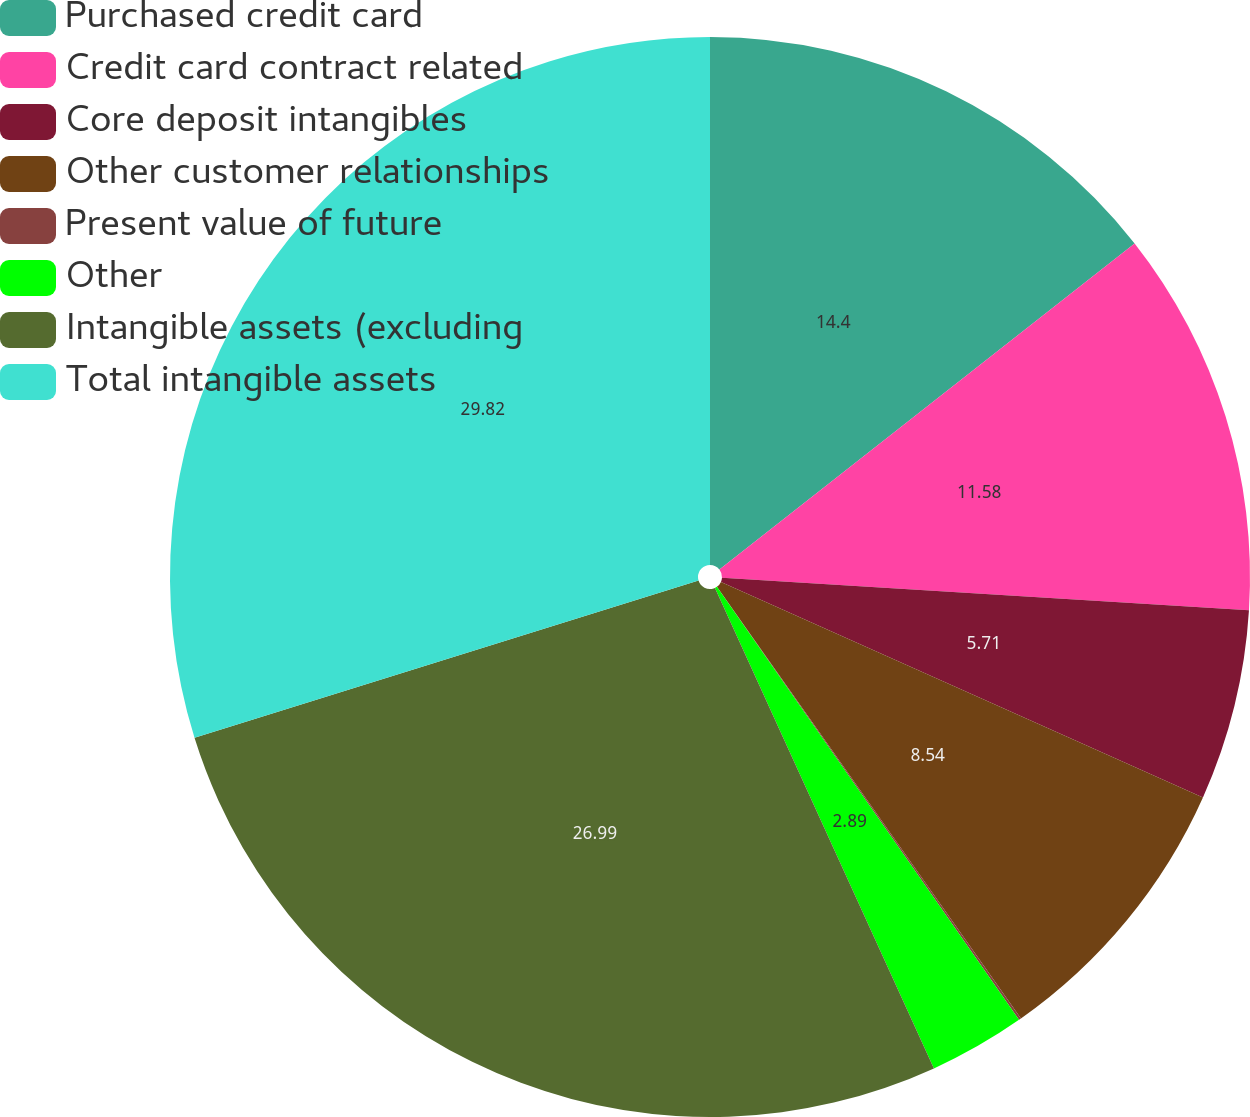<chart> <loc_0><loc_0><loc_500><loc_500><pie_chart><fcel>Purchased credit card<fcel>Credit card contract related<fcel>Core deposit intangibles<fcel>Other customer relationships<fcel>Present value of future<fcel>Other<fcel>Intangible assets (excluding<fcel>Total intangible assets<nl><fcel>14.4%<fcel>11.58%<fcel>5.71%<fcel>8.54%<fcel>0.07%<fcel>2.89%<fcel>26.99%<fcel>29.81%<nl></chart> 